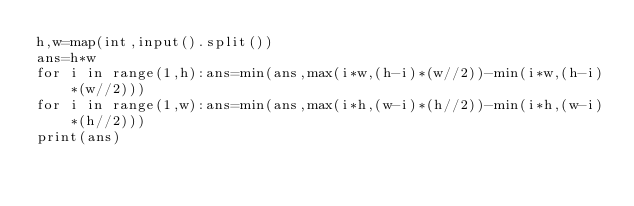Convert code to text. <code><loc_0><loc_0><loc_500><loc_500><_Python_>h,w=map(int,input().split())
ans=h*w
for i in range(1,h):ans=min(ans,max(i*w,(h-i)*(w//2))-min(i*w,(h-i)*(w//2)))
for i in range(1,w):ans=min(ans,max(i*h,(w-i)*(h//2))-min(i*h,(w-i)*(h//2)))
print(ans)</code> 